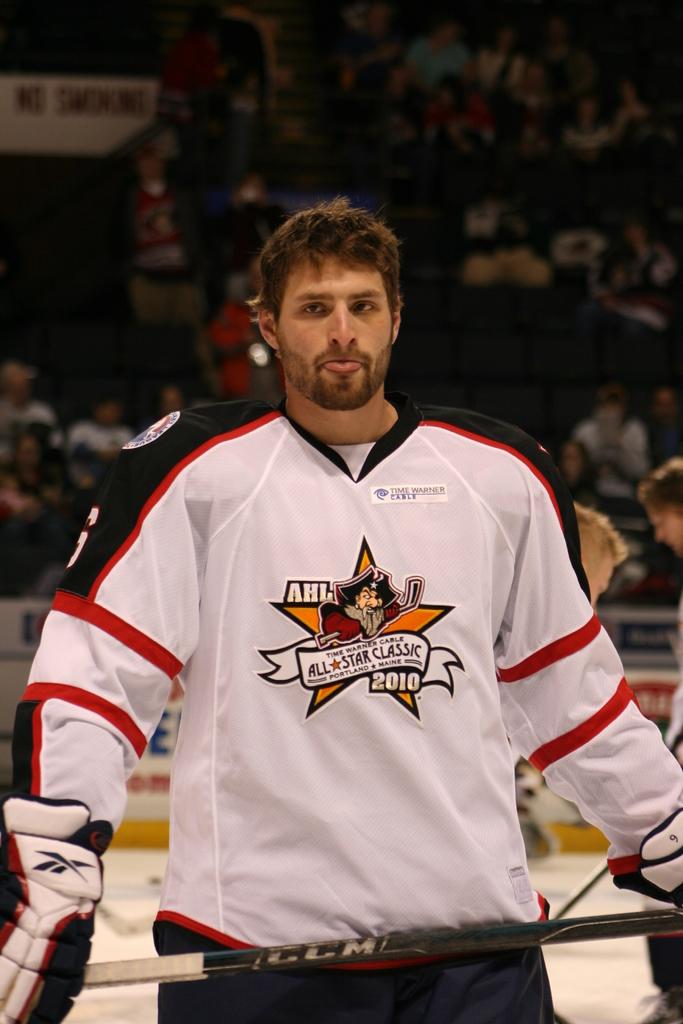What year is on his jersey?
Offer a very short reply. 2010. Does he play for the ahl?
Your answer should be compact. Yes. 